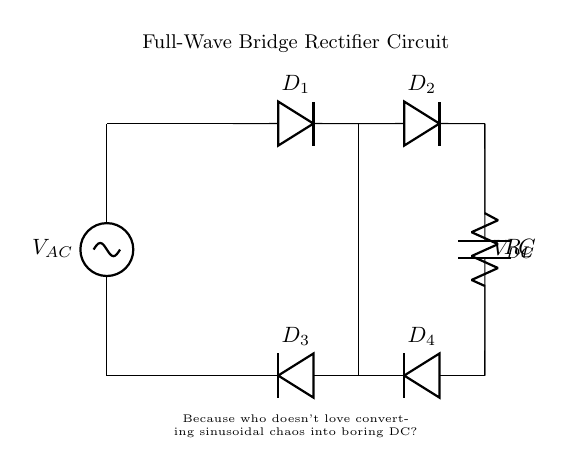What is the load resistor in this circuit? The load resistor is represented by the symbol R_L, which is used to draw current from the output of the rectifier.
Answer: R_L How many diodes are in this full-wave bridge rectifier circuit? The circuit shows four diodes (D_1, D_2, D_3, D_4) that are responsible for converting AC voltage to DC.
Answer: Four What component is used for smoothing the output voltage? The smoothing capacitor is labeled as C, and it helps reduce the ripple in the DC output voltage.
Answer: C What type of current does this circuit convert? The circuit converts alternating current (AC) from the source to direct current (DC) for use in appliances.
Answer: Alternating current What is the function of the diodes in the circuit? The diodes allow current to flow in one direction only, which results in the conversion of the AC input to a unidirectional output.
Answer: Convert AC to DC What happens to the voltage across the load resistor during a complete cycle of AC input? During a complete AC cycle, the voltage across the load resistor will vary but will ultimately provide a smoother DC voltage after rectification and filtering.
Answer: Varies Why is a full-wave bridge rectifier preferred over a half-wave rectifier? A full-wave bridge rectifier provides higher efficiency by utilizing both halves of the AC cycle, resulting in a smoother DC output with less ripple.
Answer: Higher efficiency 